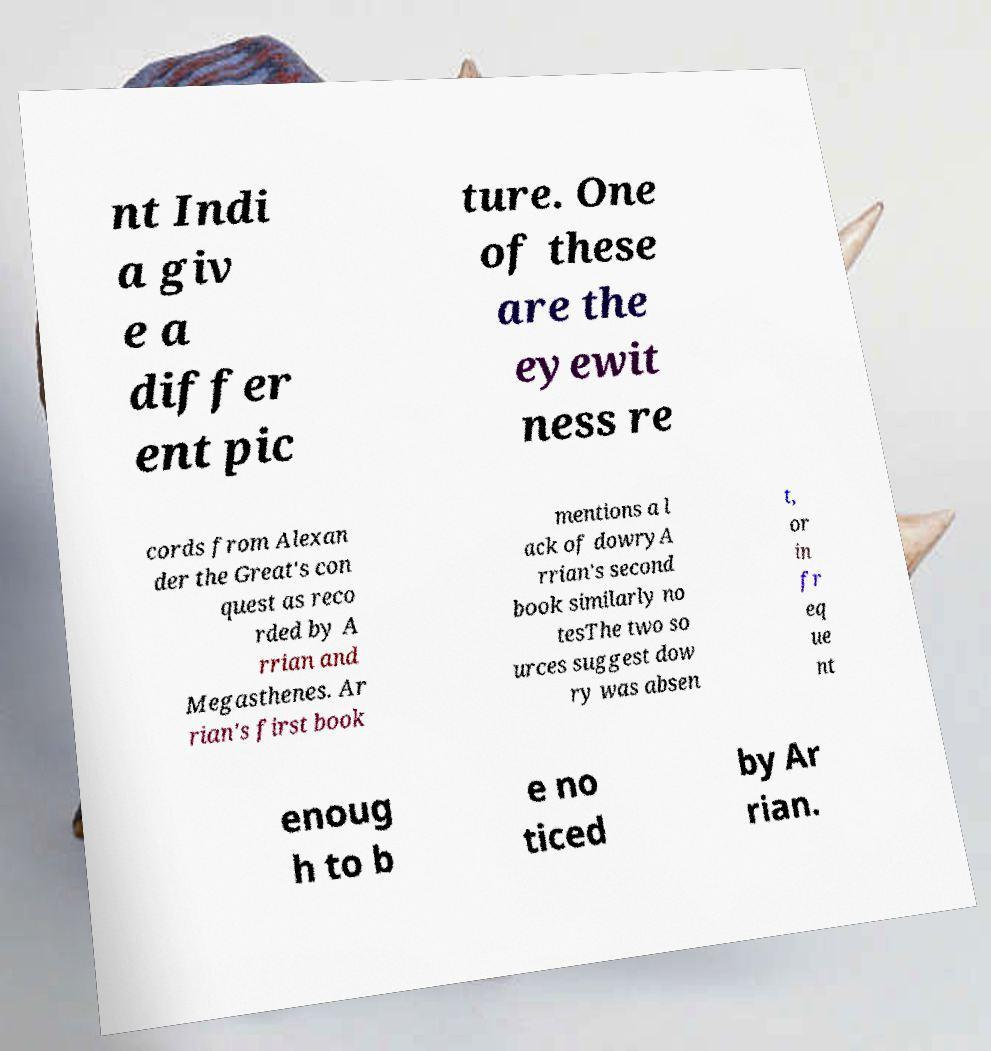For documentation purposes, I need the text within this image transcribed. Could you provide that? nt Indi a giv e a differ ent pic ture. One of these are the eyewit ness re cords from Alexan der the Great's con quest as reco rded by A rrian and Megasthenes. Ar rian's first book mentions a l ack of dowryA rrian's second book similarly no tesThe two so urces suggest dow ry was absen t, or in fr eq ue nt enoug h to b e no ticed by Ar rian. 